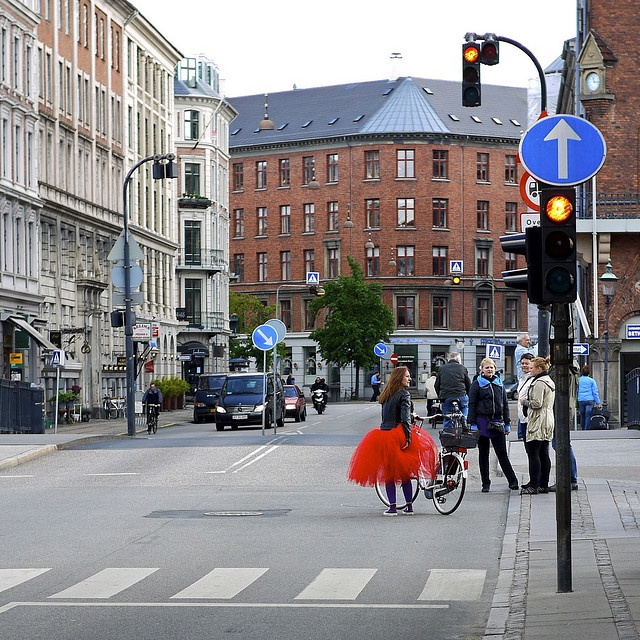Describe the objects in this image and their specific colors. I can see people in darkgray, brown, red, black, and maroon tones, traffic light in darkgray, black, gold, gray, and ivory tones, traffic light in darkgray, black, gold, yellow, and red tones, people in darkgray, black, navy, and gray tones, and bicycle in darkgray, black, lightgray, and gray tones in this image. 